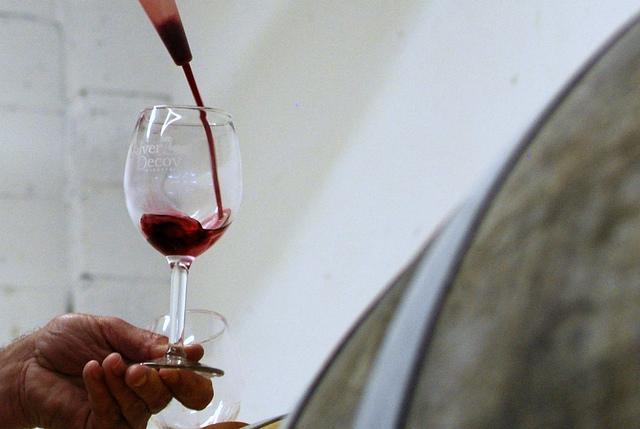What color is the wall?
Quick response, please. White. What color of wine is being poured?
Give a very brief answer. Red. What is going on here?
Write a very short answer. Pouring wine. 